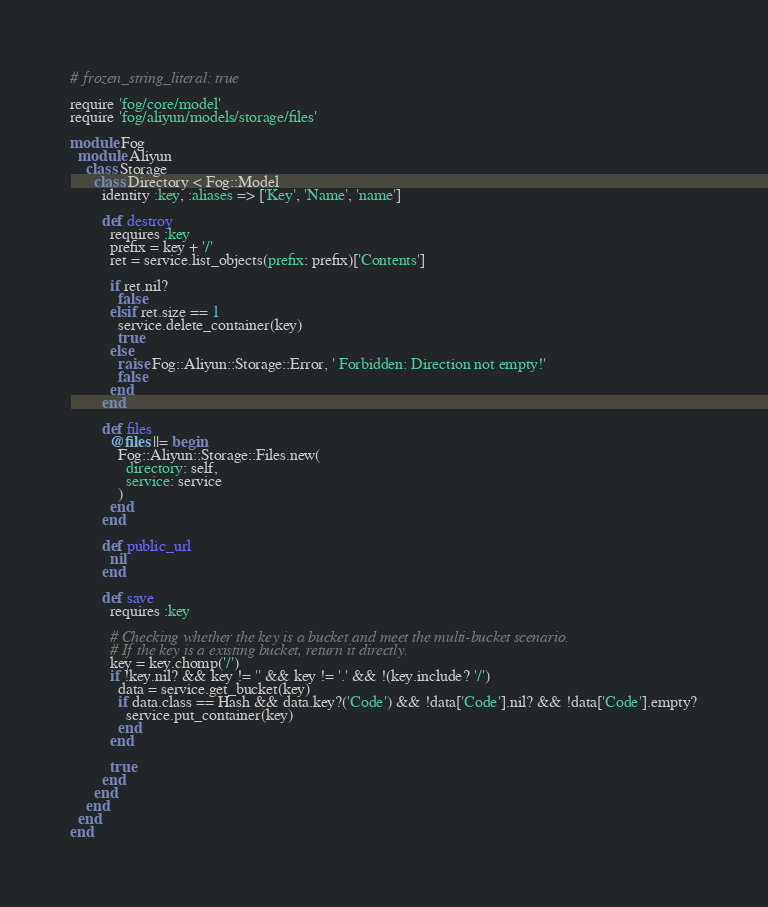Convert code to text. <code><loc_0><loc_0><loc_500><loc_500><_Ruby_># frozen_string_literal: true

require 'fog/core/model'
require 'fog/aliyun/models/storage/files'

module Fog
  module Aliyun
    class Storage
      class Directory < Fog::Model
        identity :key, :aliases => ['Key', 'Name', 'name']

        def destroy
          requires :key
          prefix = key + '/'
          ret = service.list_objects(prefix: prefix)['Contents']

          if ret.nil?
            false
          elsif ret.size == 1
            service.delete_container(key)
            true
          else
            raise Fog::Aliyun::Storage::Error, ' Forbidden: Direction not empty!'
            false
          end
        end

        def files
          @files ||= begin
            Fog::Aliyun::Storage::Files.new(
              directory: self,
              service: service
            )
          end
        end

        def public_url
          nil
        end

        def save
          requires :key

          # Checking whether the key is a bucket and meet the multi-bucket scenario.
          # If the key is a existing bucket, return it directly.
          key = key.chomp('/')
          if !key.nil? && key != '' && key != '.' && !(key.include? '/')
            data = service.get_bucket(key)
            if data.class == Hash && data.key?('Code') && !data['Code'].nil? && !data['Code'].empty?
              service.put_container(key)
            end
          end

          true
        end
      end
    end
  end
end
</code> 